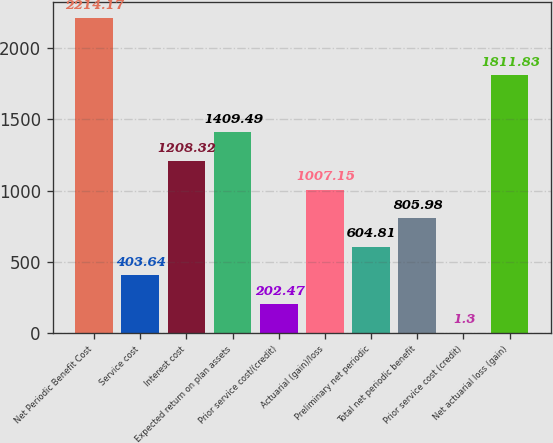Convert chart to OTSL. <chart><loc_0><loc_0><loc_500><loc_500><bar_chart><fcel>Net Periodic Benefit Cost<fcel>Service cost<fcel>Interest cost<fcel>Expected return on plan assets<fcel>Prior service cost/(credit)<fcel>Actuarial (gain)/loss<fcel>Preliminary net periodic<fcel>Total net periodic benefit<fcel>Prior service cost (credit)<fcel>Net actuarial loss (gain)<nl><fcel>2214.17<fcel>403.64<fcel>1208.32<fcel>1409.49<fcel>202.47<fcel>1007.15<fcel>604.81<fcel>805.98<fcel>1.3<fcel>1811.83<nl></chart> 